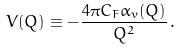Convert formula to latex. <formula><loc_0><loc_0><loc_500><loc_500>V ( Q ) \equiv - \frac { 4 \pi C _ { F } \alpha _ { v } ( Q ) } { Q ^ { 2 } } \, .</formula> 